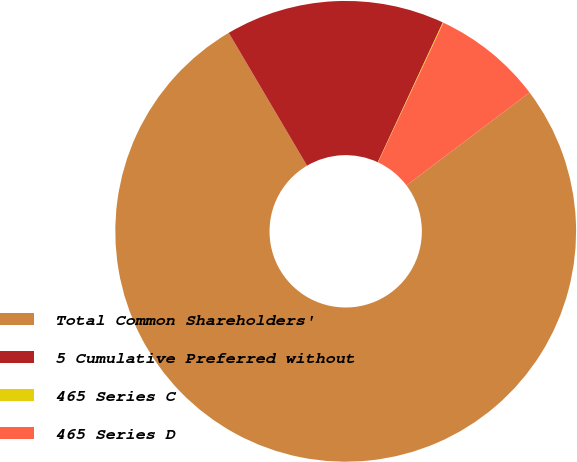<chart> <loc_0><loc_0><loc_500><loc_500><pie_chart><fcel>Total Common Shareholders'<fcel>5 Cumulative Preferred without<fcel>465 Series C<fcel>465 Series D<nl><fcel>76.82%<fcel>15.4%<fcel>0.05%<fcel>7.73%<nl></chart> 